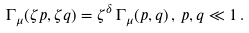<formula> <loc_0><loc_0><loc_500><loc_500>\Gamma _ { \mu } ( \zeta p , \zeta q ) = \zeta ^ { \delta } \, \Gamma _ { \mu } ( p , q ) \, , \, p , q \ll 1 \, .</formula> 